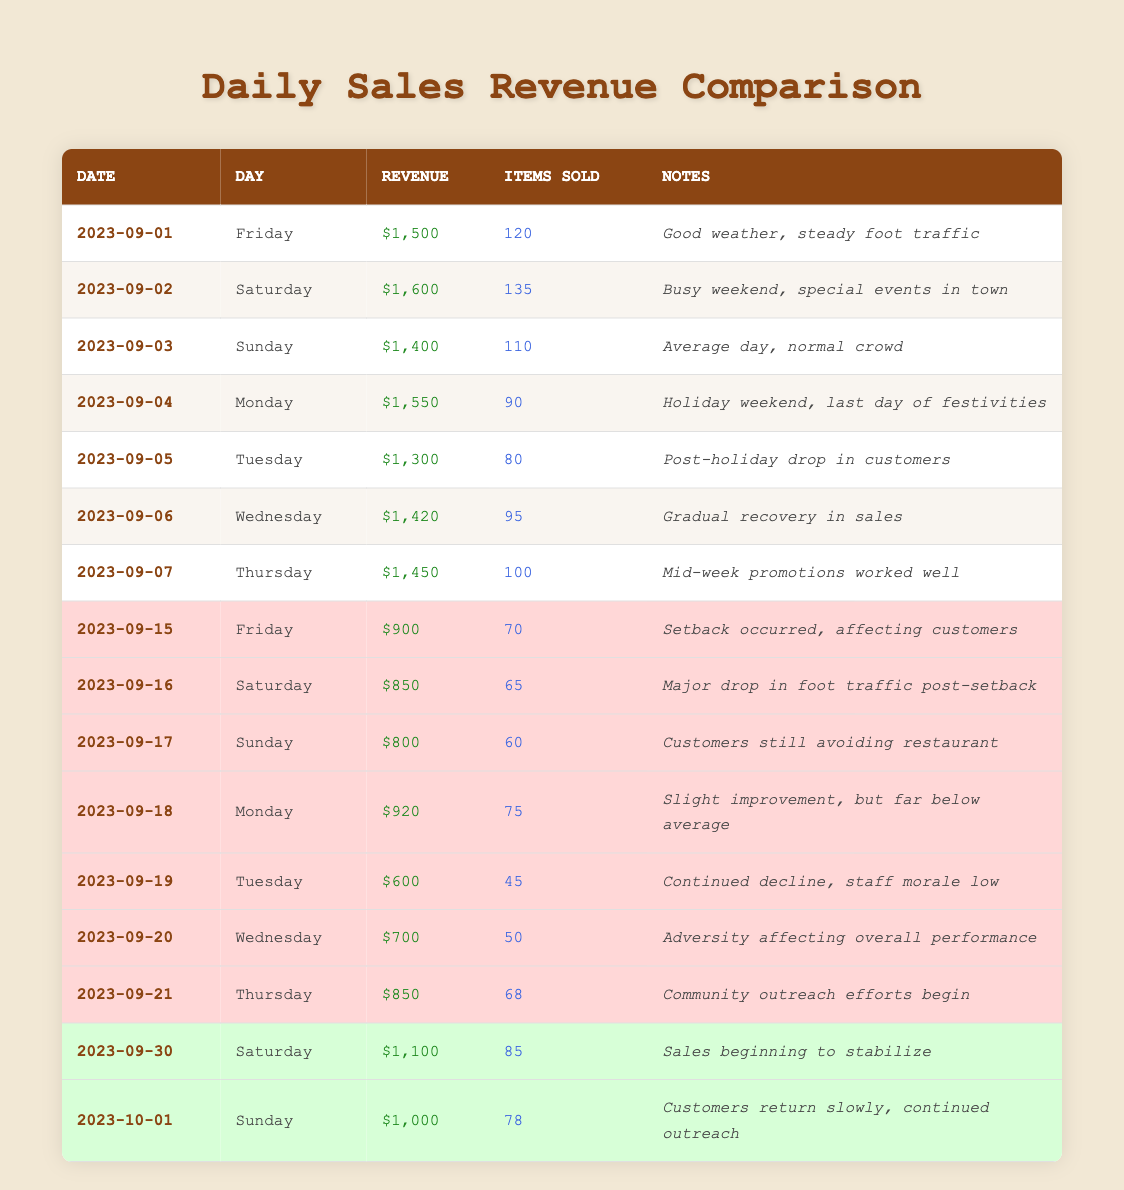What was the sales revenue on September 2, 2023? According to the table, the sales revenue for September 2, 2023, is specifically listed. By looking at the corresponding row, I can see the revenue amount is $1,600.
Answer: $1,600 How many items were sold on September 21, 2023? The table indicates the number of items sold for each date. Referring to the row for September 21, 2023, I can find that 68 items were sold on that day.
Answer: 68 What was the total sales revenue from September 15 to 20, 2023? To find the total sales revenue for this period, I will sum up the sales revenue from each day in that range: $900 (Sep 15) + $850 (Sep 16) + $800 (Sep 17) + $920 (Sep 18) + $600 (Sep 19) + $700 (Sep 20) = $4,270.
Answer: $4,270 Did the sales revenue increase on October 1, 2023, compared to September 30, 2023? I will check the revenue on both dates. On September 30, 2023, the revenue was $1,100, while on October 1, 2023, it was $1,000. Since $1,000 is less than $1,100, the revenue did not increase; it actually decreased.
Answer: No What is the average sales revenue per day from September 1 to 7, 2023? First, I will total the sales revenue from September 1 to 7: $1,500 + $1,600 + $1,400 + $1,550 + $1,300 + $1,420 + $1,450 = $10,220. There are 7 days in this period, so the average is $10,220 ÷ 7 ≈ $1,460.
Answer: $1,460 Was there an increase in the number of items sold on September 30, 2023, compared to September 23, 2023? Looking at the table, September 30, 2023, shows 85 items sold. However, September 23 is not listed in the data provided. Therefore, I cannot compare the number of items sold on these dates.
Answer: Not applicable On which date did the restaurant experience the lowest sales revenue after the setback? Looking at the entries after the setback, I can see the sales revenue on September 19, 2023, is the lowest at $600. This is the smallest value compared to other entries after that date.
Answer: September 19, 2023 How many total items were sold between September 15 and September 21, 2023? I will sum the items sold during this period: 70 (Sep 15) + 65 (Sep 16) + 60 (Sep 17) + 75 (Sep 18) + 45 (Sep 19) + 50 (Sep 20) + 68 (Sep 21) = 453. Thus, the total items sold is 453.
Answer: 453 Was there a recovery in sales revenue on October 1, 2023, from the previous days in September? Comparing the revenue on October 1, 2023 ($1,000) with the last several days in September (e.g., September 30 $1,100, September 29 not available but the trend suggests continued decline based on earlier days), I can see that October 1 is lower than September 30. Therefore, there was no recovery in that context.
Answer: No 